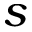Convert formula to latex. <formula><loc_0><loc_0><loc_500><loc_500>s</formula> 